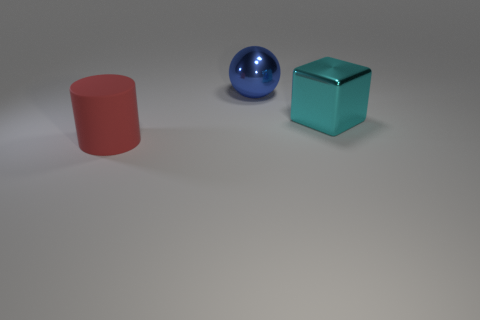Are there any other things that are made of the same material as the red cylinder?
Keep it short and to the point. No. How many large things are metal spheres or green things?
Provide a short and direct response. 1. How many big things are behind the cylinder and in front of the ball?
Your response must be concise. 1. Is the blue ball made of the same material as the large thing that is right of the blue sphere?
Make the answer very short. Yes. How many red things are tiny shiny cubes or large objects?
Offer a terse response. 1. Is there another metallic object of the same size as the cyan thing?
Offer a very short reply. Yes. There is a large object right of the big metallic thing that is behind the large metallic object in front of the blue sphere; what is it made of?
Offer a very short reply. Metal. Are there an equal number of large blue things on the left side of the blue thing and small blue rubber balls?
Provide a short and direct response. Yes. Does the object that is to the right of the ball have the same material as the thing that is to the left of the large metal sphere?
Ensure brevity in your answer.  No. What number of objects are big metal things or large objects behind the red object?
Give a very brief answer. 2. 